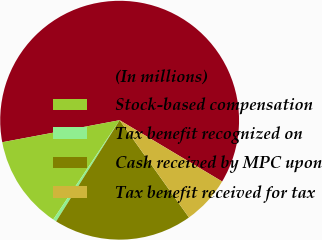Convert chart to OTSL. <chart><loc_0><loc_0><loc_500><loc_500><pie_chart><fcel>(In millions)<fcel>Stock-based compensation<fcel>Tax benefit recognized on<fcel>Cash received by MPC upon<fcel>Tax benefit received for tax<nl><fcel>61.53%<fcel>12.67%<fcel>0.46%<fcel>18.78%<fcel>6.57%<nl></chart> 